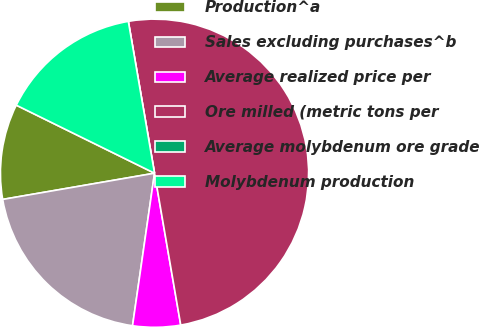Convert chart to OTSL. <chart><loc_0><loc_0><loc_500><loc_500><pie_chart><fcel>Production^a<fcel>Sales excluding purchases^b<fcel>Average realized price per<fcel>Ore milled (metric tons per<fcel>Average molybdenum ore grade<fcel>Molybdenum production<nl><fcel>10.0%<fcel>20.0%<fcel>5.0%<fcel>50.0%<fcel>0.0%<fcel>15.0%<nl></chart> 